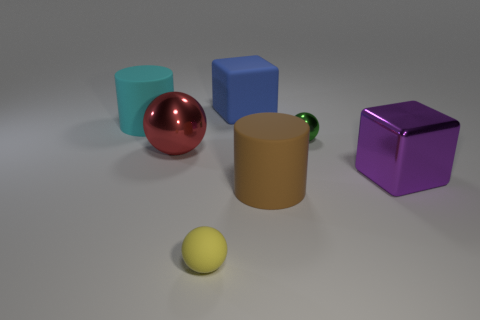Add 1 cylinders. How many objects exist? 8 Subtract all blocks. How many objects are left? 5 Subtract all purple metallic cylinders. Subtract all large blue matte objects. How many objects are left? 6 Add 7 blue matte objects. How many blue matte objects are left? 8 Add 7 large red balls. How many large red balls exist? 8 Subtract 0 yellow cubes. How many objects are left? 7 